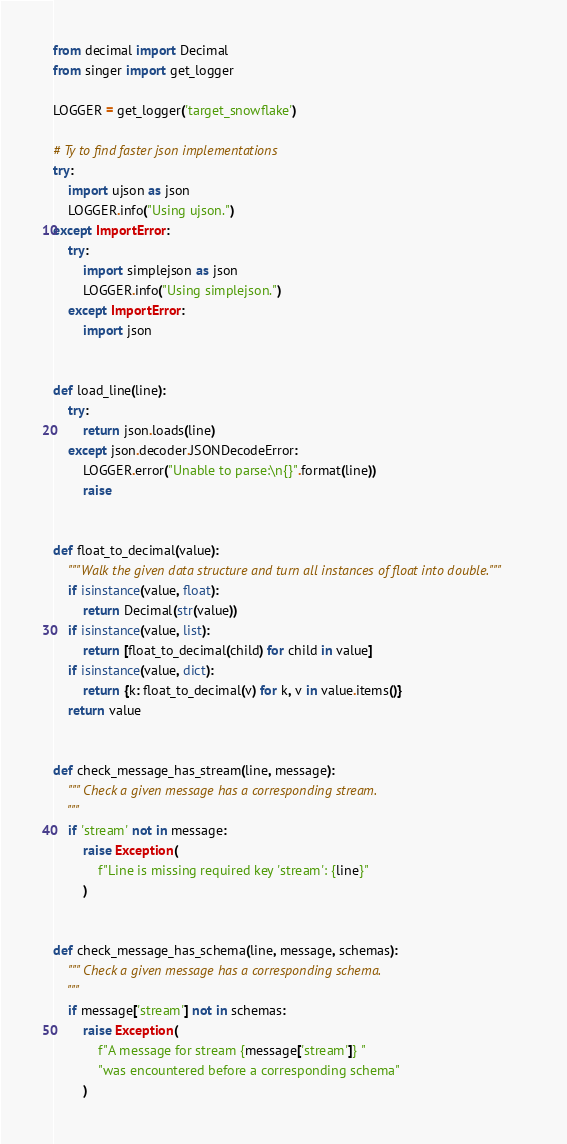Convert code to text. <code><loc_0><loc_0><loc_500><loc_500><_Python_>from decimal import Decimal
from singer import get_logger

LOGGER = get_logger('target_snowflake')

# Ty to find faster json implementations
try:
    import ujson as json
    LOGGER.info("Using ujson.")
except ImportError:
    try:
        import simplejson as json
        LOGGER.info("Using simplejson.")
    except ImportError:
        import json


def load_line(line):
    try:
        return json.loads(line)
    except json.decoder.JSONDecodeError:
        LOGGER.error("Unable to parse:\n{}".format(line))
        raise


def float_to_decimal(value):
    """Walk the given data structure and turn all instances of float into double."""
    if isinstance(value, float):
        return Decimal(str(value))
    if isinstance(value, list):
        return [float_to_decimal(child) for child in value]
    if isinstance(value, dict):
        return {k: float_to_decimal(v) for k, v in value.items()}
    return value


def check_message_has_stream(line, message):
    """ Check a given message has a corresponding stream.
    """
    if 'stream' not in message:
        raise Exception(
            f"Line is missing required key 'stream': {line}"
        )


def check_message_has_schema(line, message, schemas):
    """ Check a given message has a corresponding schema.
    """
    if message['stream'] not in schemas:
        raise Exception(
            f"A message for stream {message['stream']} "
            "was encountered before a corresponding schema"
        )
</code> 